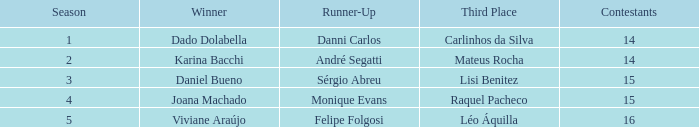Help me parse the entirety of this table. {'header': ['Season', 'Winner', 'Runner-Up', 'Third Place', 'Contestants'], 'rows': [['1', 'Dado Dolabella', 'Danni Carlos', 'Carlinhos da Silva', '14'], ['2', 'Karina Bacchi', 'André Segatti', 'Mateus Rocha', '14'], ['3', 'Daniel Bueno', 'Sérgio Abreu', 'Lisi Benitez', '15'], ['4', 'Joana Machado', 'Monique Evans', 'Raquel Pacheco', '15'], ['5', 'Viviane Araújo', 'Felipe Folgosi', 'Léo Áquilla', '16']]} How many contestants were there when the runner-up was Sérgio Abreu?  15.0. 